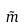<formula> <loc_0><loc_0><loc_500><loc_500>\tilde { m }</formula> 